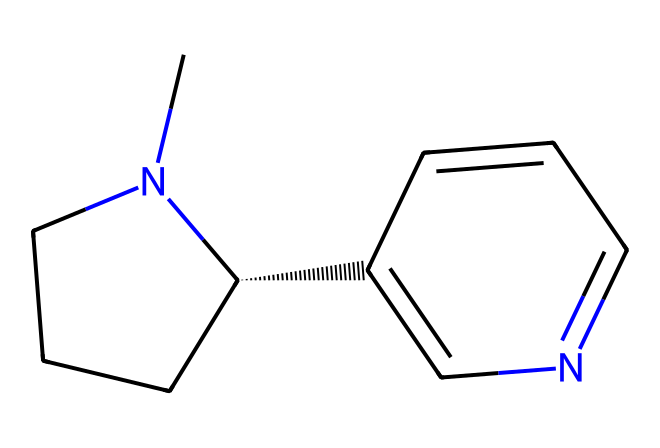What is the molecular formula of nicotine? To find the molecular formula, count the number of carbon (C), hydrogen (H), and nitrogen (N) atoms in the SMILES representation. There are 10 carbons, 14 hydrogens, and 2 nitrogens. Thus, the molecular formula is C10H14N2.
Answer: C10H14N2 How many rings are present in the nicotine structure? Analyzing the SMILES, we observe that there are two parts: a five-membered ring (1) and a six-membered ring (2), which indicates that the structure contains two rings.
Answer: 2 What type of functional groups are present in nicotine? In the structure, the presence of nitrogen atoms indicates the presence of amine groups. There are no other functional groups like alcohols or carboxylic acids in this structure.
Answer: amine If nicotine we consider halogenated derivatives, which halogens could substitute in the structure? The common halogens are fluorine, chlorine, bromine, and iodine. Each could theoretically substitute for hydrogen atoms in the nicotine structure.
Answer: fluorine, chlorine, bromine, iodine Which atom contributes to the basic characteristics of nicotine? The nitrogen atom is crucial in the structure, contributing to the basic properties due to its ability to accept protons. This imparts basicity to nicotine.
Answer: nitrogen How would you describe the overall polarity of nicotine? The presence of nitrogen atoms and their electronegativity creates polar covalent bonds, contributing to the overall polarity of the molecule. The structure is thus moderately polar.
Answer: moderately polar 